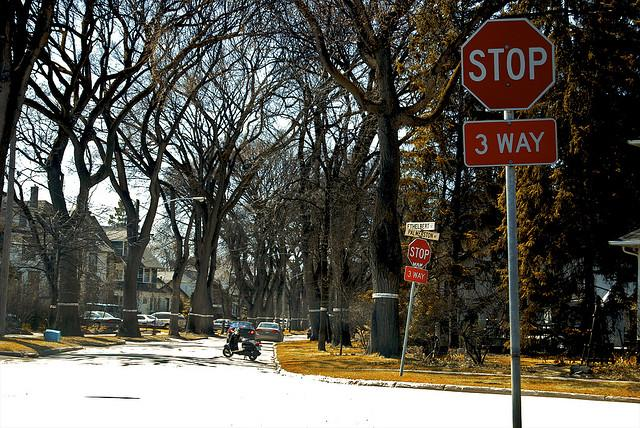How many ways are there on this stop sign? three 